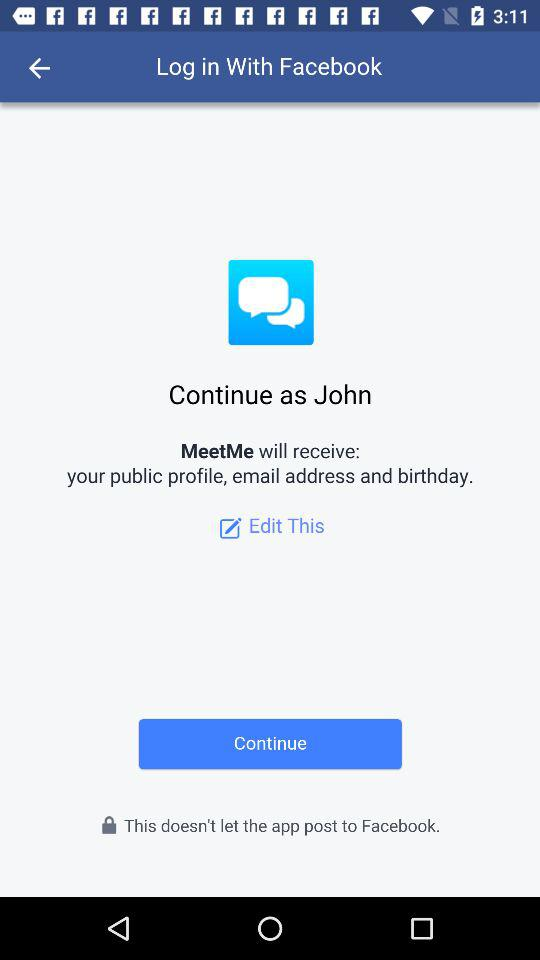Which option is selected?
When the provided information is insufficient, respond with <no answer>. <no answer> 